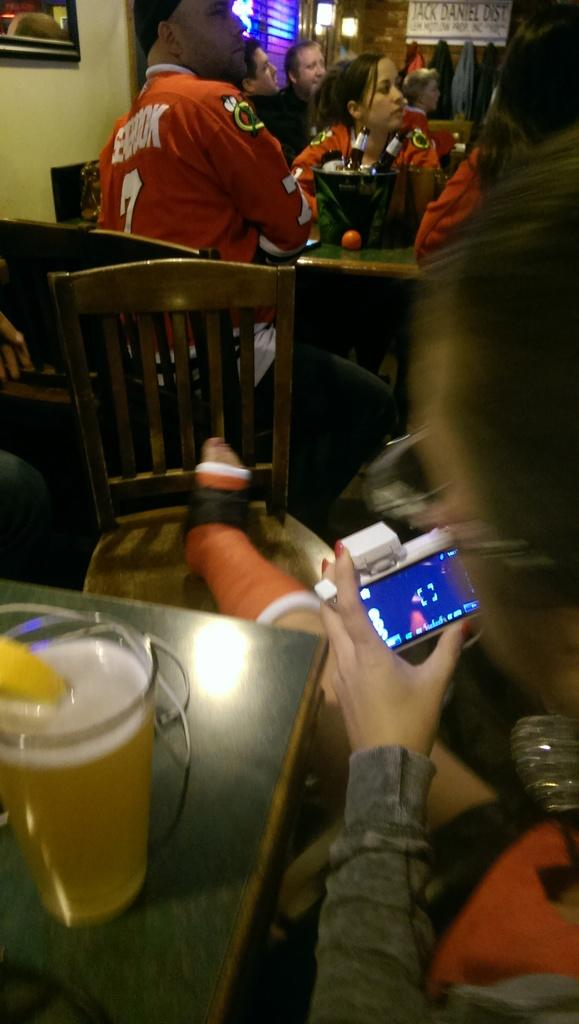What are the people in the image doing? The people in the image are sitting. What furniture is present in the image? There are chairs and tables in the image. Can you describe the object on one of the tables? There is a glass on one of the tables. What type of bird can be seen flying over the people in the image? There is no bird present in the image. How many oranges are on the table with the glass? There are no oranges present in the image. 